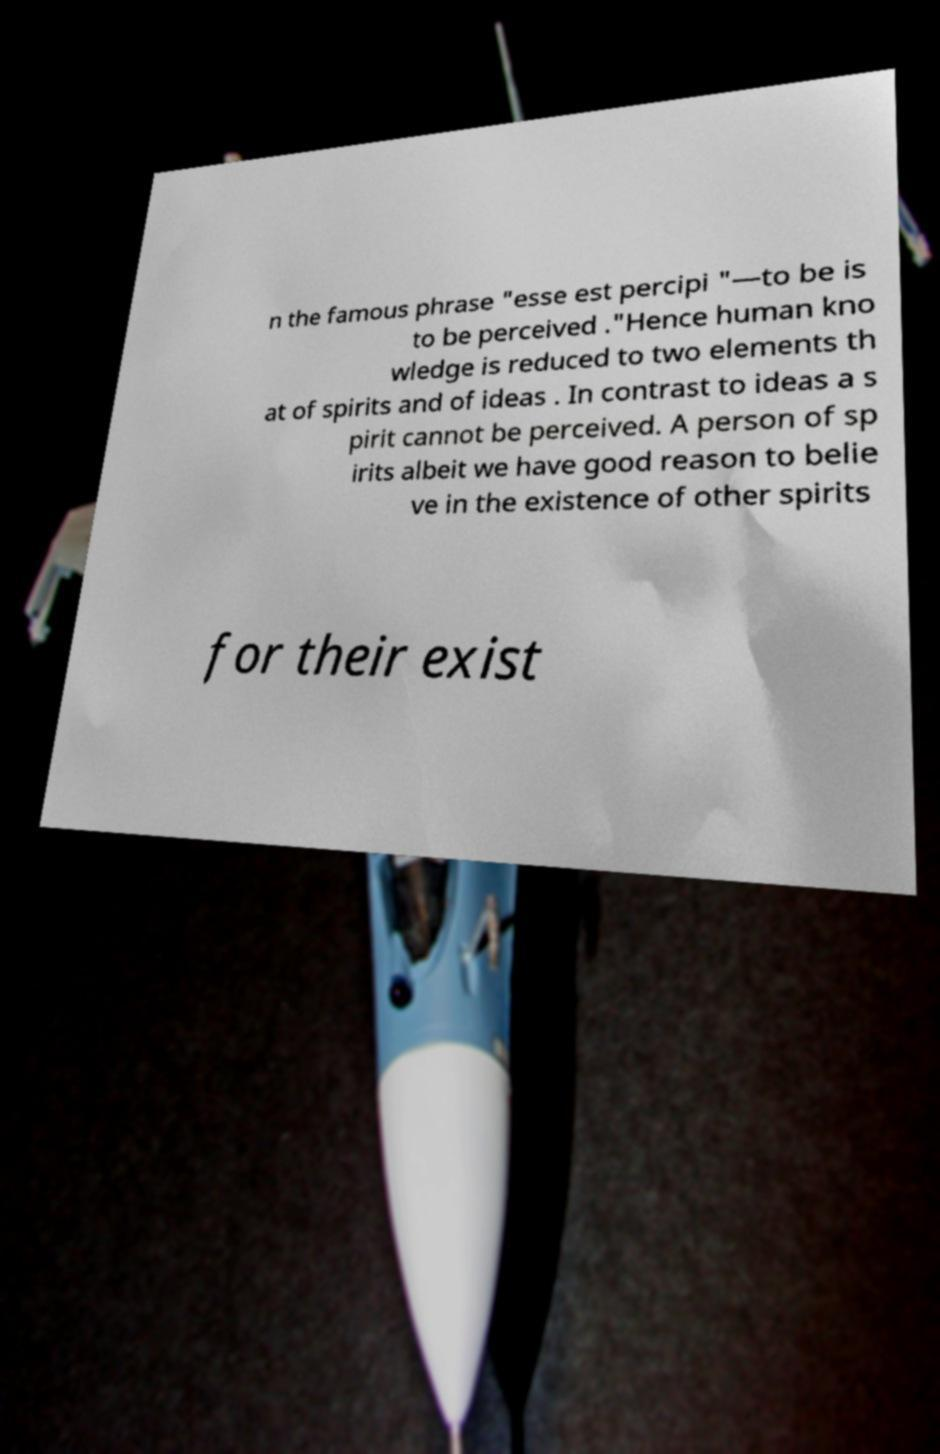For documentation purposes, I need the text within this image transcribed. Could you provide that? n the famous phrase "esse est percipi "—to be is to be perceived ."Hence human kno wledge is reduced to two elements th at of spirits and of ideas . In contrast to ideas a s pirit cannot be perceived. A person of sp irits albeit we have good reason to belie ve in the existence of other spirits for their exist 